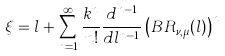Convert formula to latex. <formula><loc_0><loc_0><loc_500><loc_500>\xi = l + \sum ^ { \infty } _ { n = 1 } \frac { k ^ { n } } { n ! } \frac { d ^ { n - 1 } } { d l ^ { n - 1 } } \left ( B R _ { \nu , \mu } ( l ) \right ) ^ { n }</formula> 